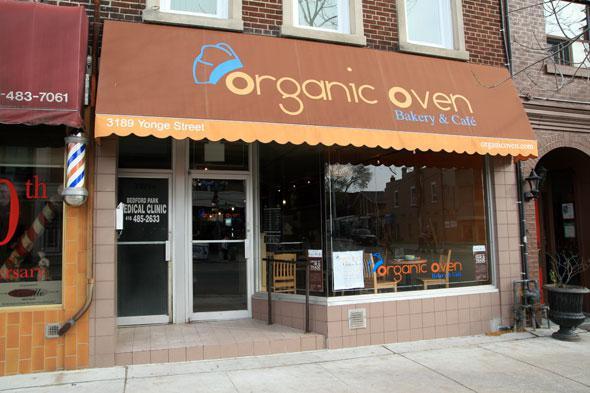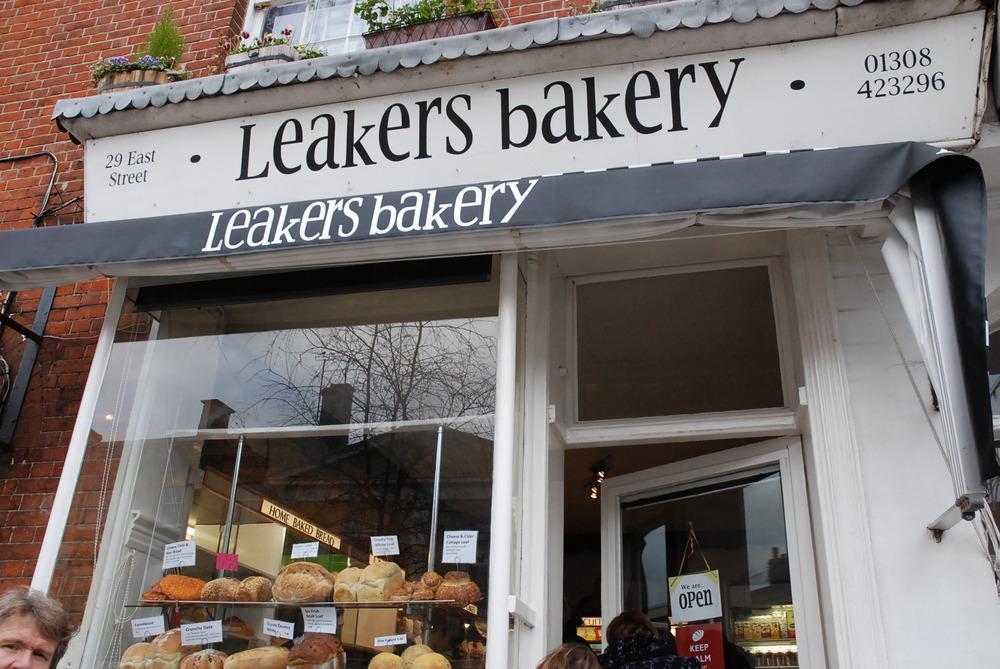The first image is the image on the left, the second image is the image on the right. Given the left and right images, does the statement "Front doors are visible in both images." hold true? Answer yes or no. Yes. The first image is the image on the left, the second image is the image on the right. Examine the images to the left and right. Is the description "One of the store fronts has a brown awning." accurate? Answer yes or no. Yes. 